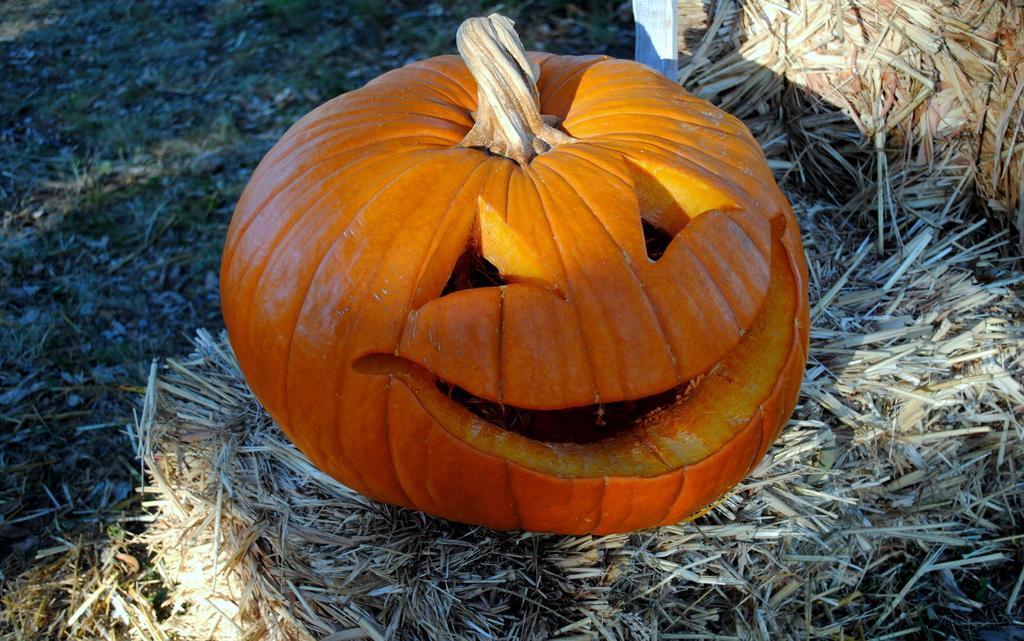Could you give a brief overview of what you see in this image? In this image I can see dry grass and on it I can see an orange colour pumpkin. 